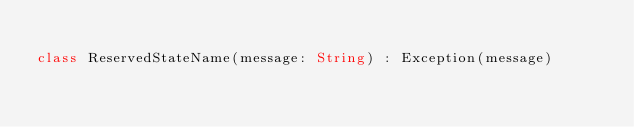Convert code to text. <code><loc_0><loc_0><loc_500><loc_500><_Kotlin_>
class ReservedStateName(message: String) : Exception(message)</code> 